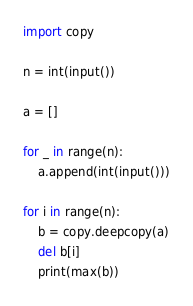Convert code to text. <code><loc_0><loc_0><loc_500><loc_500><_Python_>import copy

n = int(input())

a = []

for _ in range(n):
    a.append(int(input()))

for i in range(n):
    b = copy.deepcopy(a)
    del b[i]
    print(max(b))
</code> 